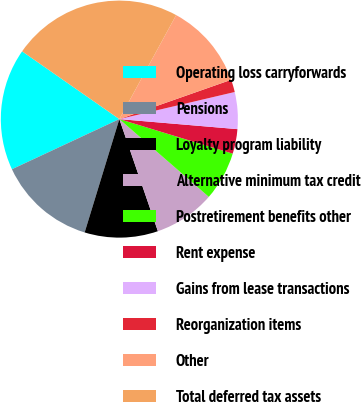<chart> <loc_0><loc_0><loc_500><loc_500><pie_chart><fcel>Operating loss carryforwards<fcel>Pensions<fcel>Loyalty program liability<fcel>Alternative minimum tax credit<fcel>Postretirement benefits other<fcel>Rent expense<fcel>Gains from lease transactions<fcel>Reorganization items<fcel>Other<fcel>Total deferred tax assets<nl><fcel>16.64%<fcel>13.32%<fcel>10.0%<fcel>8.34%<fcel>6.68%<fcel>3.36%<fcel>5.02%<fcel>1.71%<fcel>11.66%<fcel>23.27%<nl></chart> 